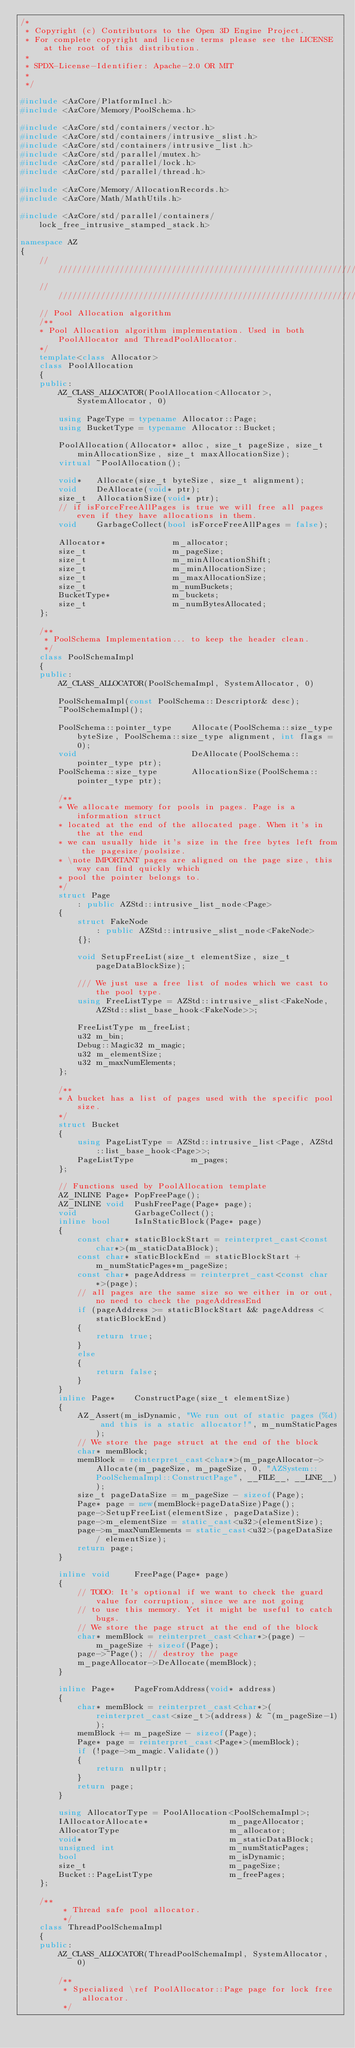Convert code to text. <code><loc_0><loc_0><loc_500><loc_500><_C++_>/*
 * Copyright (c) Contributors to the Open 3D Engine Project.
 * For complete copyright and license terms please see the LICENSE at the root of this distribution.
 *
 * SPDX-License-Identifier: Apache-2.0 OR MIT
 *
 */

#include <AzCore/PlatformIncl.h>
#include <AzCore/Memory/PoolSchema.h>

#include <AzCore/std/containers/vector.h>
#include <AzCore/std/containers/intrusive_slist.h>
#include <AzCore/std/containers/intrusive_list.h>
#include <AzCore/std/parallel/mutex.h>
#include <AzCore/std/parallel/lock.h>
#include <AzCore/std/parallel/thread.h>

#include <AzCore/Memory/AllocationRecords.h>
#include <AzCore/Math/MathUtils.h>

#include <AzCore/std/parallel/containers/lock_free_intrusive_stamped_stack.h>

namespace AZ
{
    //////////////////////////////////////////////////////////////////////////
    //////////////////////////////////////////////////////////////////////////
    // Pool Allocation algorithm
    /**
    * Pool Allocation algorithm implementation. Used in both PoolAllocator and ThreadPoolAllocator.
    */
    template<class Allocator>
    class PoolAllocation
    {
    public:
        AZ_CLASS_ALLOCATOR(PoolAllocation<Allocator>, SystemAllocator, 0)

        using PageType = typename Allocator::Page;
        using BucketType = typename Allocator::Bucket;

        PoolAllocation(Allocator* alloc, size_t pageSize, size_t minAllocationSize, size_t maxAllocationSize);
        virtual ~PoolAllocation();

        void*   Allocate(size_t byteSize, size_t alignment);
        void    DeAllocate(void* ptr);
        size_t  AllocationSize(void* ptr);
        // if isForceFreeAllPages is true we will free all pages even if they have allocations in them.
        void    GarbageCollect(bool isForceFreeAllPages = false);

        Allocator*              m_allocator;
        size_t                  m_pageSize;
        size_t                  m_minAllocationShift;
        size_t                  m_minAllocationSize;
        size_t                  m_maxAllocationSize;
        size_t                  m_numBuckets;
        BucketType*             m_buckets;
        size_t                  m_numBytesAllocated;
    };

    /**
     * PoolSchema Implementation... to keep the header clean.
     */
    class PoolSchemaImpl
    {
    public:
        AZ_CLASS_ALLOCATOR(PoolSchemaImpl, SystemAllocator, 0)

        PoolSchemaImpl(const PoolSchema::Descriptor& desc);
        ~PoolSchemaImpl();

        PoolSchema::pointer_type    Allocate(PoolSchema::size_type byteSize, PoolSchema::size_type alignment, int flags = 0);
        void                        DeAllocate(PoolSchema::pointer_type ptr);
        PoolSchema::size_type       AllocationSize(PoolSchema::pointer_type ptr);

        /**
        * We allocate memory for pools in pages. Page is a information struct
        * located at the end of the allocated page. When it's in the at the end
        * we can usually hide it's size in the free bytes left from the pagesize/poolsize.
        * \note IMPORTANT pages are aligned on the page size, this way can find quickly which
        * pool the pointer belongs to.
        */
        struct Page
            : public AZStd::intrusive_list_node<Page>
        {
            struct FakeNode
                : public AZStd::intrusive_slist_node<FakeNode>
            {};

            void SetupFreeList(size_t elementSize, size_t pageDataBlockSize);

            /// We just use a free list of nodes which we cast to the pool type.
            using FreeListType = AZStd::intrusive_slist<FakeNode, AZStd::slist_base_hook<FakeNode>>;

            FreeListType m_freeList;
            u32 m_bin;
            Debug::Magic32 m_magic;
            u32 m_elementSize;
            u32 m_maxNumElements;
        };

        /**
        * A bucket has a list of pages used with the specific pool size.
        */
        struct Bucket
        {
            using PageListType = AZStd::intrusive_list<Page, AZStd::list_base_hook<Page>>;
            PageListType            m_pages;
        };

        // Functions used by PoolAllocation template
        AZ_INLINE Page* PopFreePage();
        AZ_INLINE void  PushFreePage(Page* page);
        void            GarbageCollect();
        inline bool     IsInStaticBlock(Page* page)
        {
            const char* staticBlockStart = reinterpret_cast<const char*>(m_staticDataBlock);
            const char* staticBlockEnd = staticBlockStart + m_numStaticPages*m_pageSize;
            const char* pageAddress = reinterpret_cast<const char*>(page);
            // all pages are the same size so we either in or out, no need to check the pageAddressEnd
            if (pageAddress >= staticBlockStart && pageAddress < staticBlockEnd)
            {
                return true;
            }
            else
            {
                return false;
            }
        }
        inline Page*    ConstructPage(size_t elementSize)
        {
            AZ_Assert(m_isDynamic, "We run out of static pages (%d) and this is a static allocator!", m_numStaticPages);
            // We store the page struct at the end of the block
            char* memBlock;
            memBlock = reinterpret_cast<char*>(m_pageAllocator->Allocate(m_pageSize, m_pageSize, 0, "AZSystem::PoolSchemaImpl::ConstructPage", __FILE__, __LINE__));
            size_t pageDataSize = m_pageSize - sizeof(Page);
            Page* page = new(memBlock+pageDataSize)Page();
            page->SetupFreeList(elementSize, pageDataSize);
            page->m_elementSize = static_cast<u32>(elementSize);
            page->m_maxNumElements = static_cast<u32>(pageDataSize / elementSize);
            return page;
        }

        inline void     FreePage(Page* page)
        {
            // TODO: It's optional if we want to check the guard value for corruption, since we are not going
            // to use this memory. Yet it might be useful to catch bugs.
            // We store the page struct at the end of the block
            char* memBlock = reinterpret_cast<char*>(page) - m_pageSize + sizeof(Page);
            page->~Page(); // destroy the page
            m_pageAllocator->DeAllocate(memBlock);
        }

        inline Page*    PageFromAddress(void* address)
        {
            char* memBlock = reinterpret_cast<char*>(reinterpret_cast<size_t>(address) & ~(m_pageSize-1));
            memBlock += m_pageSize - sizeof(Page);
            Page* page = reinterpret_cast<Page*>(memBlock);
            if (!page->m_magic.Validate())
            {
                return nullptr;
            }
            return page;
        }

        using AllocatorType = PoolAllocation<PoolSchemaImpl>;
        IAllocatorAllocate*                 m_pageAllocator;
        AllocatorType                       m_allocator;
        void*                               m_staticDataBlock;
        unsigned int                        m_numStaticPages;
        bool                                m_isDynamic;
        size_t                              m_pageSize;
        Bucket::PageListType                m_freePages;
    };

    /**
         * Thread safe pool allocator.
         */
    class ThreadPoolSchemaImpl
    {
    public:
        AZ_CLASS_ALLOCATOR(ThreadPoolSchemaImpl, SystemAllocator, 0)

        /**
         * Specialized \ref PoolAllocator::Page page for lock free allocator.
         */</code> 